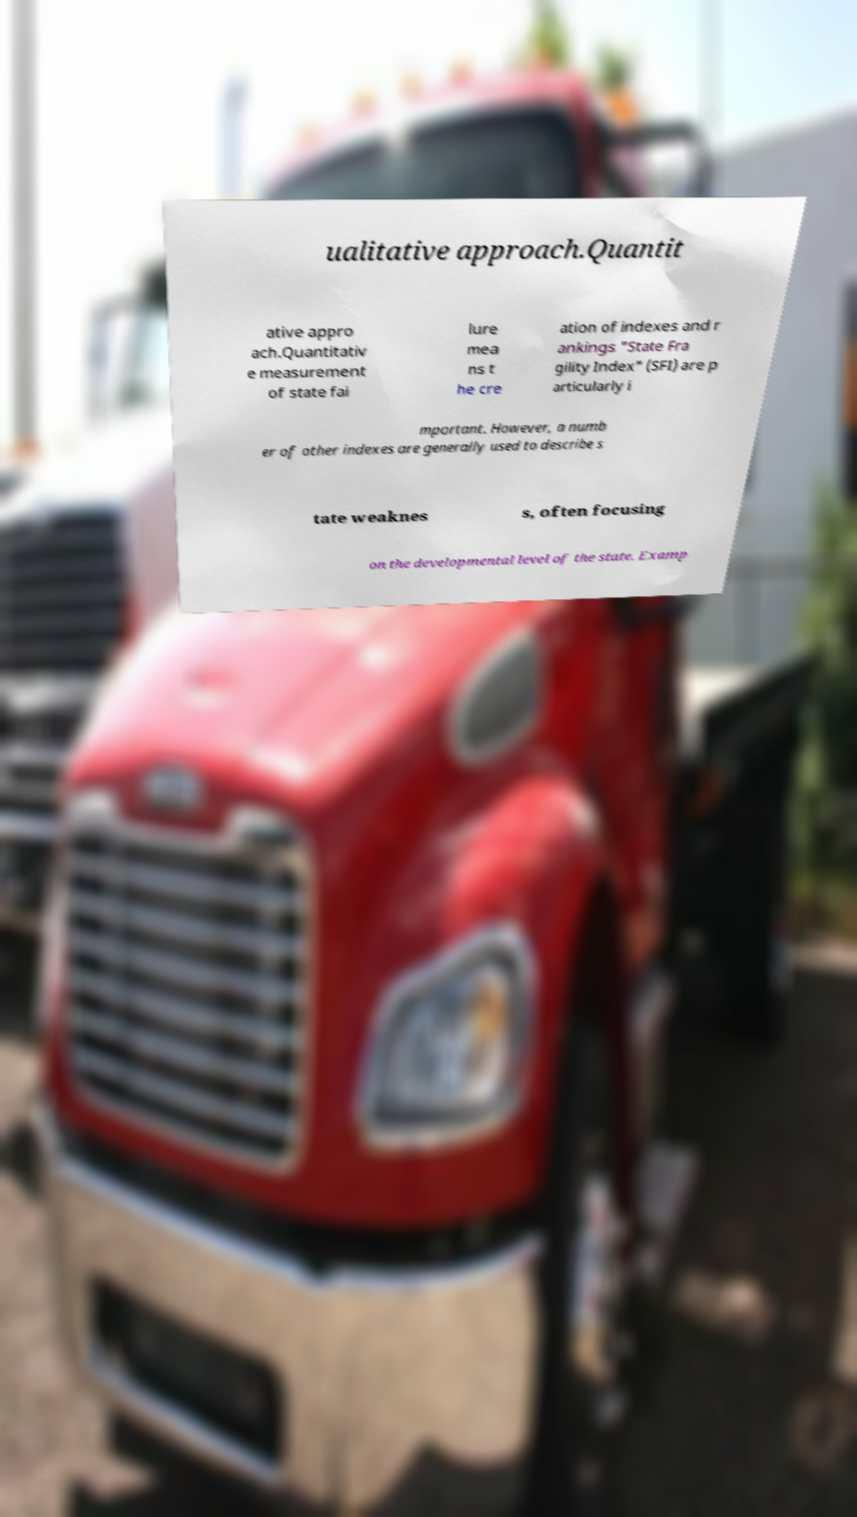Please read and relay the text visible in this image. What does it say? ualitative approach.Quantit ative appro ach.Quantitativ e measurement of state fai lure mea ns t he cre ation of indexes and r ankings "State Fra gility Index" (SFI) are p articularly i mportant. However, a numb er of other indexes are generally used to describe s tate weaknes s, often focusing on the developmental level of the state. Examp 